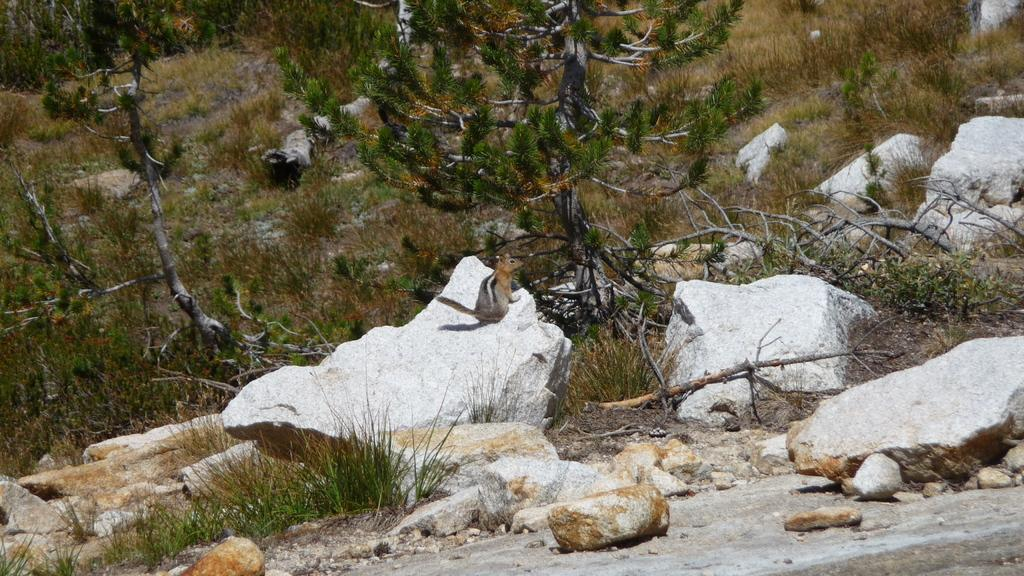What animal can be seen in the image? There is a squirrel on a rock in the image. What type of terrain is visible in the image? There are rocks, branches, grass, and trees visible in the image. Can you describe the squirrel's location in the image? The squirrel is on a rock in the image. What is the purpose of the yoke in the image? There is no yoke present in the image. How many brothers are visible in the image? There are no people, let alone brothers, visible in the image. 